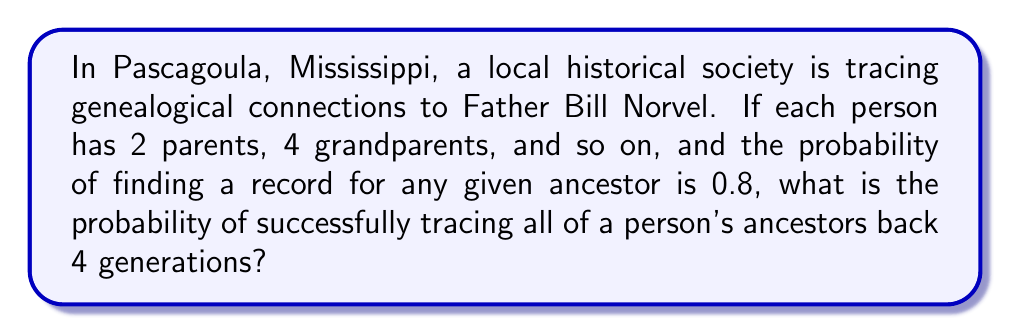Solve this math problem. Let's approach this step-by-step:

1) First, let's calculate the number of ancestors in 4 generations:
   - 1st generation (parents): $2^1 = 2$
   - 2nd generation (grandparents): $2^2 = 4$
   - 3rd generation (great-grandparents): $2^3 = 8$
   - 4th generation (great-great-grandparents): $2^4 = 16$

   Total ancestors: $2 + 4 + 8 + 16 = 30$

2) The probability of finding a record for any single ancestor is 0.8.

3) To successfully trace all ancestors, we need to find records for all 30 ancestors. This is a case of independent events, so we multiply the probabilities.

4) The probability of success is therefore:

   $$(0.8)^{30}$$

5) Let's calculate this:
   $$(0.8)^{30} \approx 0.0012 \text{ or } 0.12\%$$

This very low probability highlights the difficulty of tracing complete ancestral lines over multiple generations, even with a relatively high success rate for individual records.
Answer: $$(0.8)^{30} \approx 0.0012$$ 